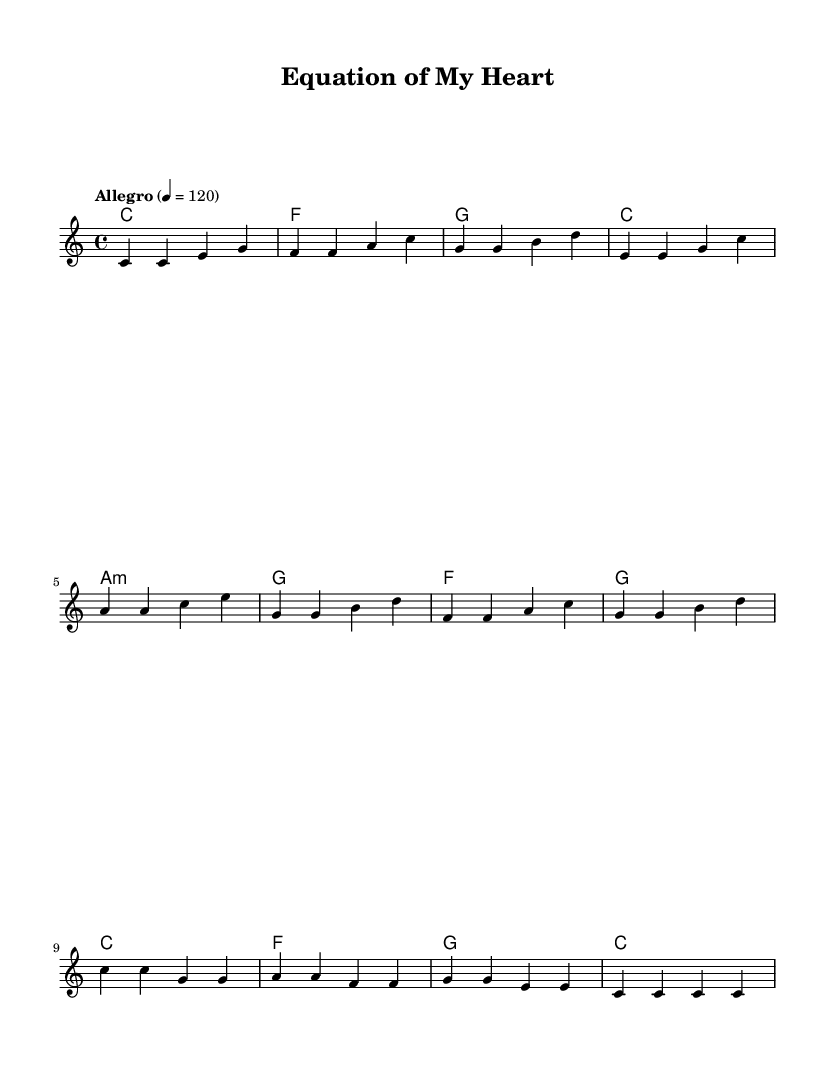What is the key signature of this music? The key signature is C major, which has no sharps or flats.
Answer: C major What is the time signature of this music? The time signature is identified in the score with the notation 4/4, indicating four beats in each measure.
Answer: 4/4 What is the tempo indication? The tempo marking states "Allegro" and provides a metronome marking of 120 beats per minute, indicating a fast pace.
Answer: Allegro 4 = 120 How many measures are in the verse section? By counting the measures in the melody section under Verse, there are four measures present.
Answer: 4 What chord follows the "a:m" in the pre-chorus? The chord that follows the "a:m" chord in the pre-chorus is the "g" chord, as seen in the chord progression.
Answer: g What lyrical theme is suggested in the chorus? The chorus expresses a theme of love and logic being intertwined, as indicated by the lyrics, "It's the equation of my heart."
Answer: Love and logic Which mathematical concept is emphasized in the lyrics? The lyrics highlight the concept of solving equations, with mentions of "plotting points" and "solution," emphasizing mathematical problem-solving.
Answer: Solving equations 